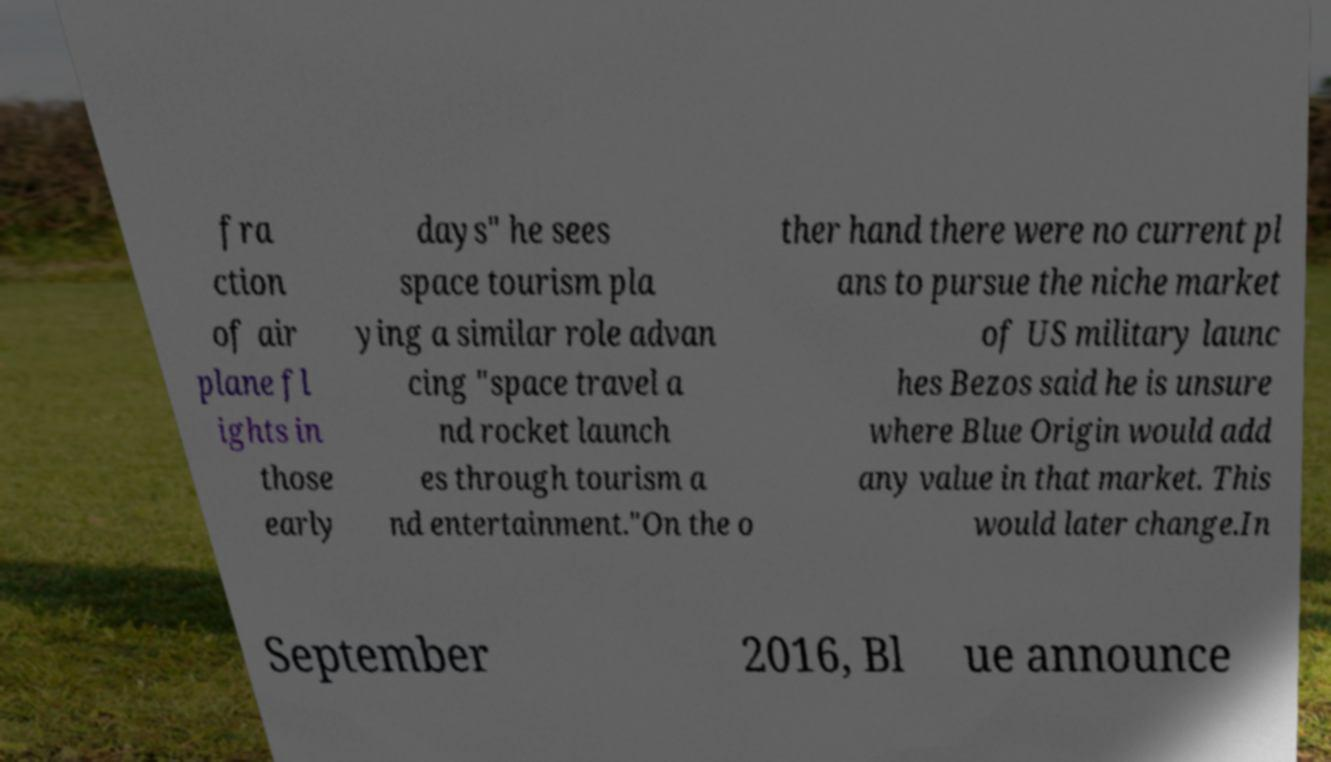Could you extract and type out the text from this image? fra ction of air plane fl ights in those early days" he sees space tourism pla ying a similar role advan cing "space travel a nd rocket launch es through tourism a nd entertainment."On the o ther hand there were no current pl ans to pursue the niche market of US military launc hes Bezos said he is unsure where Blue Origin would add any value in that market. This would later change.In September 2016, Bl ue announce 